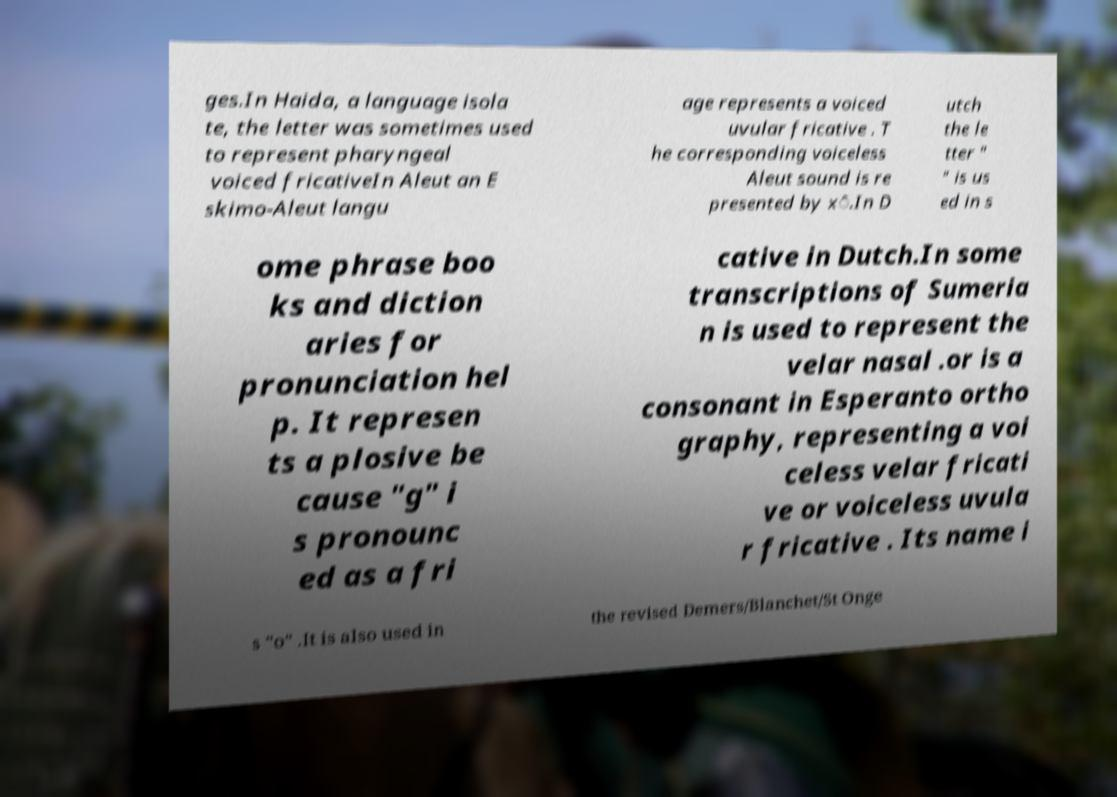For documentation purposes, I need the text within this image transcribed. Could you provide that? ges.In Haida, a language isola te, the letter was sometimes used to represent pharyngeal voiced fricativeIn Aleut an E skimo-Aleut langu age represents a voiced uvular fricative . T he corresponding voiceless Aleut sound is re presented by x̂.In D utch the le tter " " is us ed in s ome phrase boo ks and diction aries for pronunciation hel p. It represen ts a plosive be cause "g" i s pronounc ed as a fri cative in Dutch.In some transcriptions of Sumeria n is used to represent the velar nasal .or is a consonant in Esperanto ortho graphy, representing a voi celess velar fricati ve or voiceless uvula r fricative . Its name i s "o" .It is also used in the revised Demers/Blanchet/St Onge 